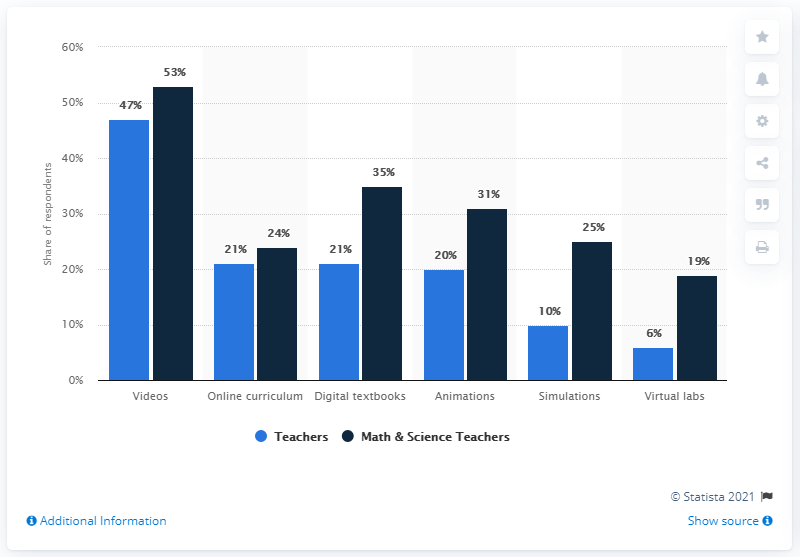Outline some significant characteristics in this image. The lowest value of blue is 6. The difference between the highest and the lowest dark blue bar is 34. 